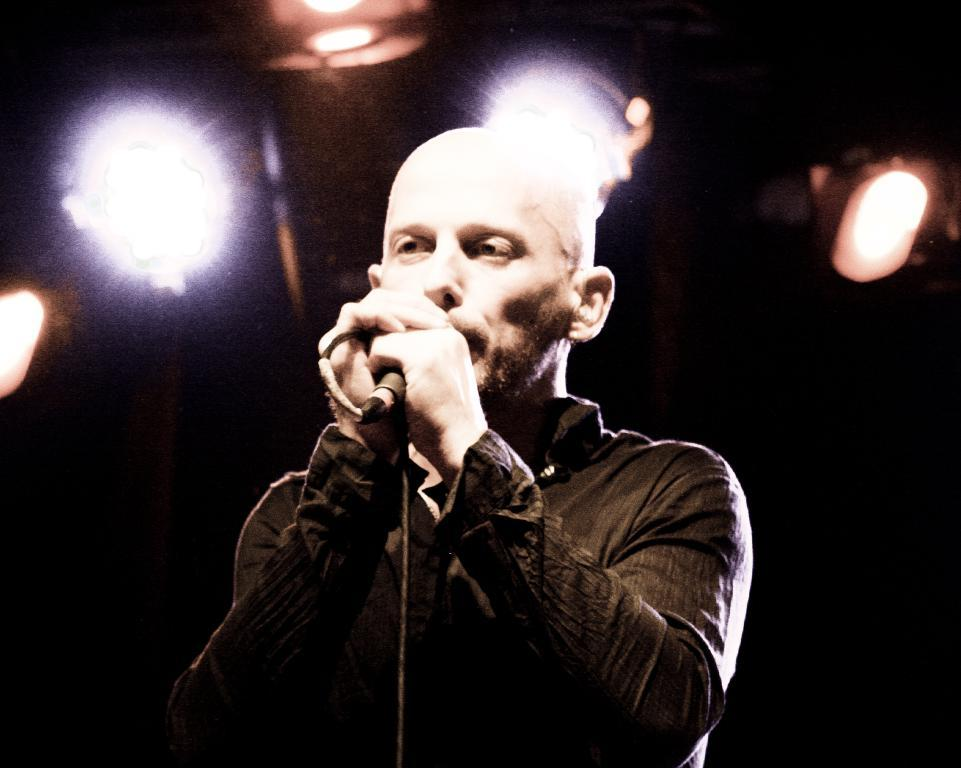Who is the person in the image? There is a man in the image. What is the man holding in the image? The man is holding a microphone. What is the man wearing in the image? The man is wearing a black shirt. What can be seen in the background of the image? There are four lights in the background. What might the man be doing in the image? The man may be singing on a stage. What type of wax can be seen melting on the books in the image? There are no books or wax present in the image. 